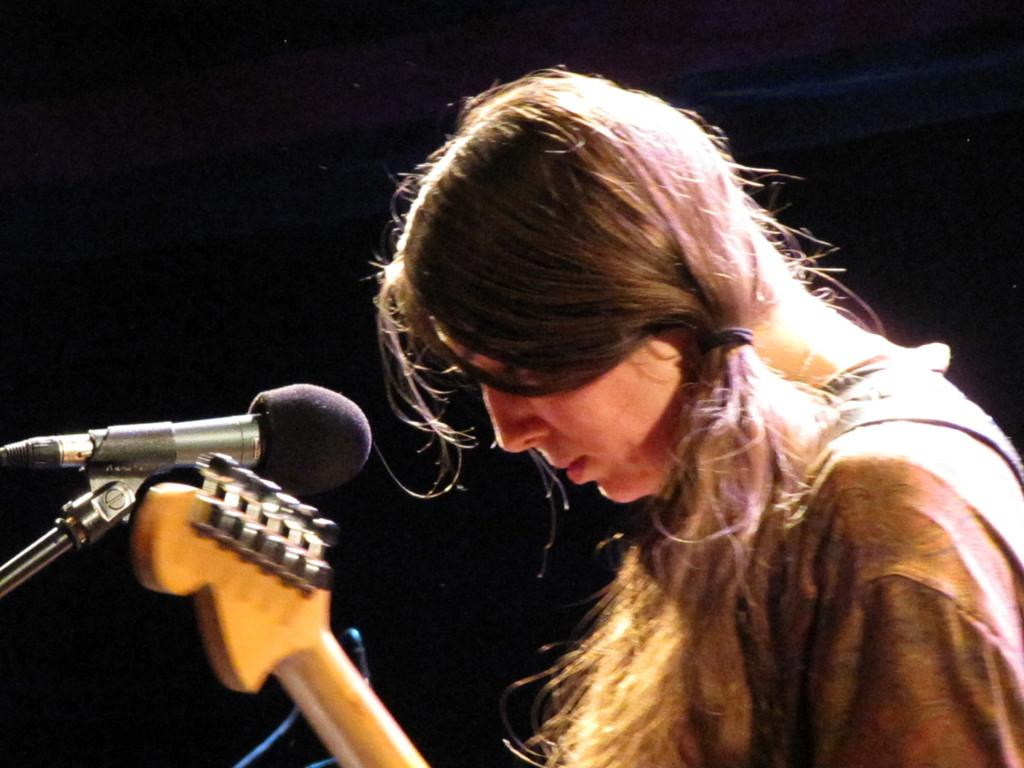Who is the main subject in the image? There is a lady in the image. What object is in front of the lady? There is a mic in front of the lady. What musical instrument can be seen in the image? There is a guitar in the image. What is the color of the background in the image? The background of the image is dark. How many toads are sitting on the guitar in the image? There are no toads present in the image, and therefore no such activity can be observed. What type of silk fabric is draped over the mic in the image? There is no silk fabric present in the image; only the lady, mic, and guitar are visible. 